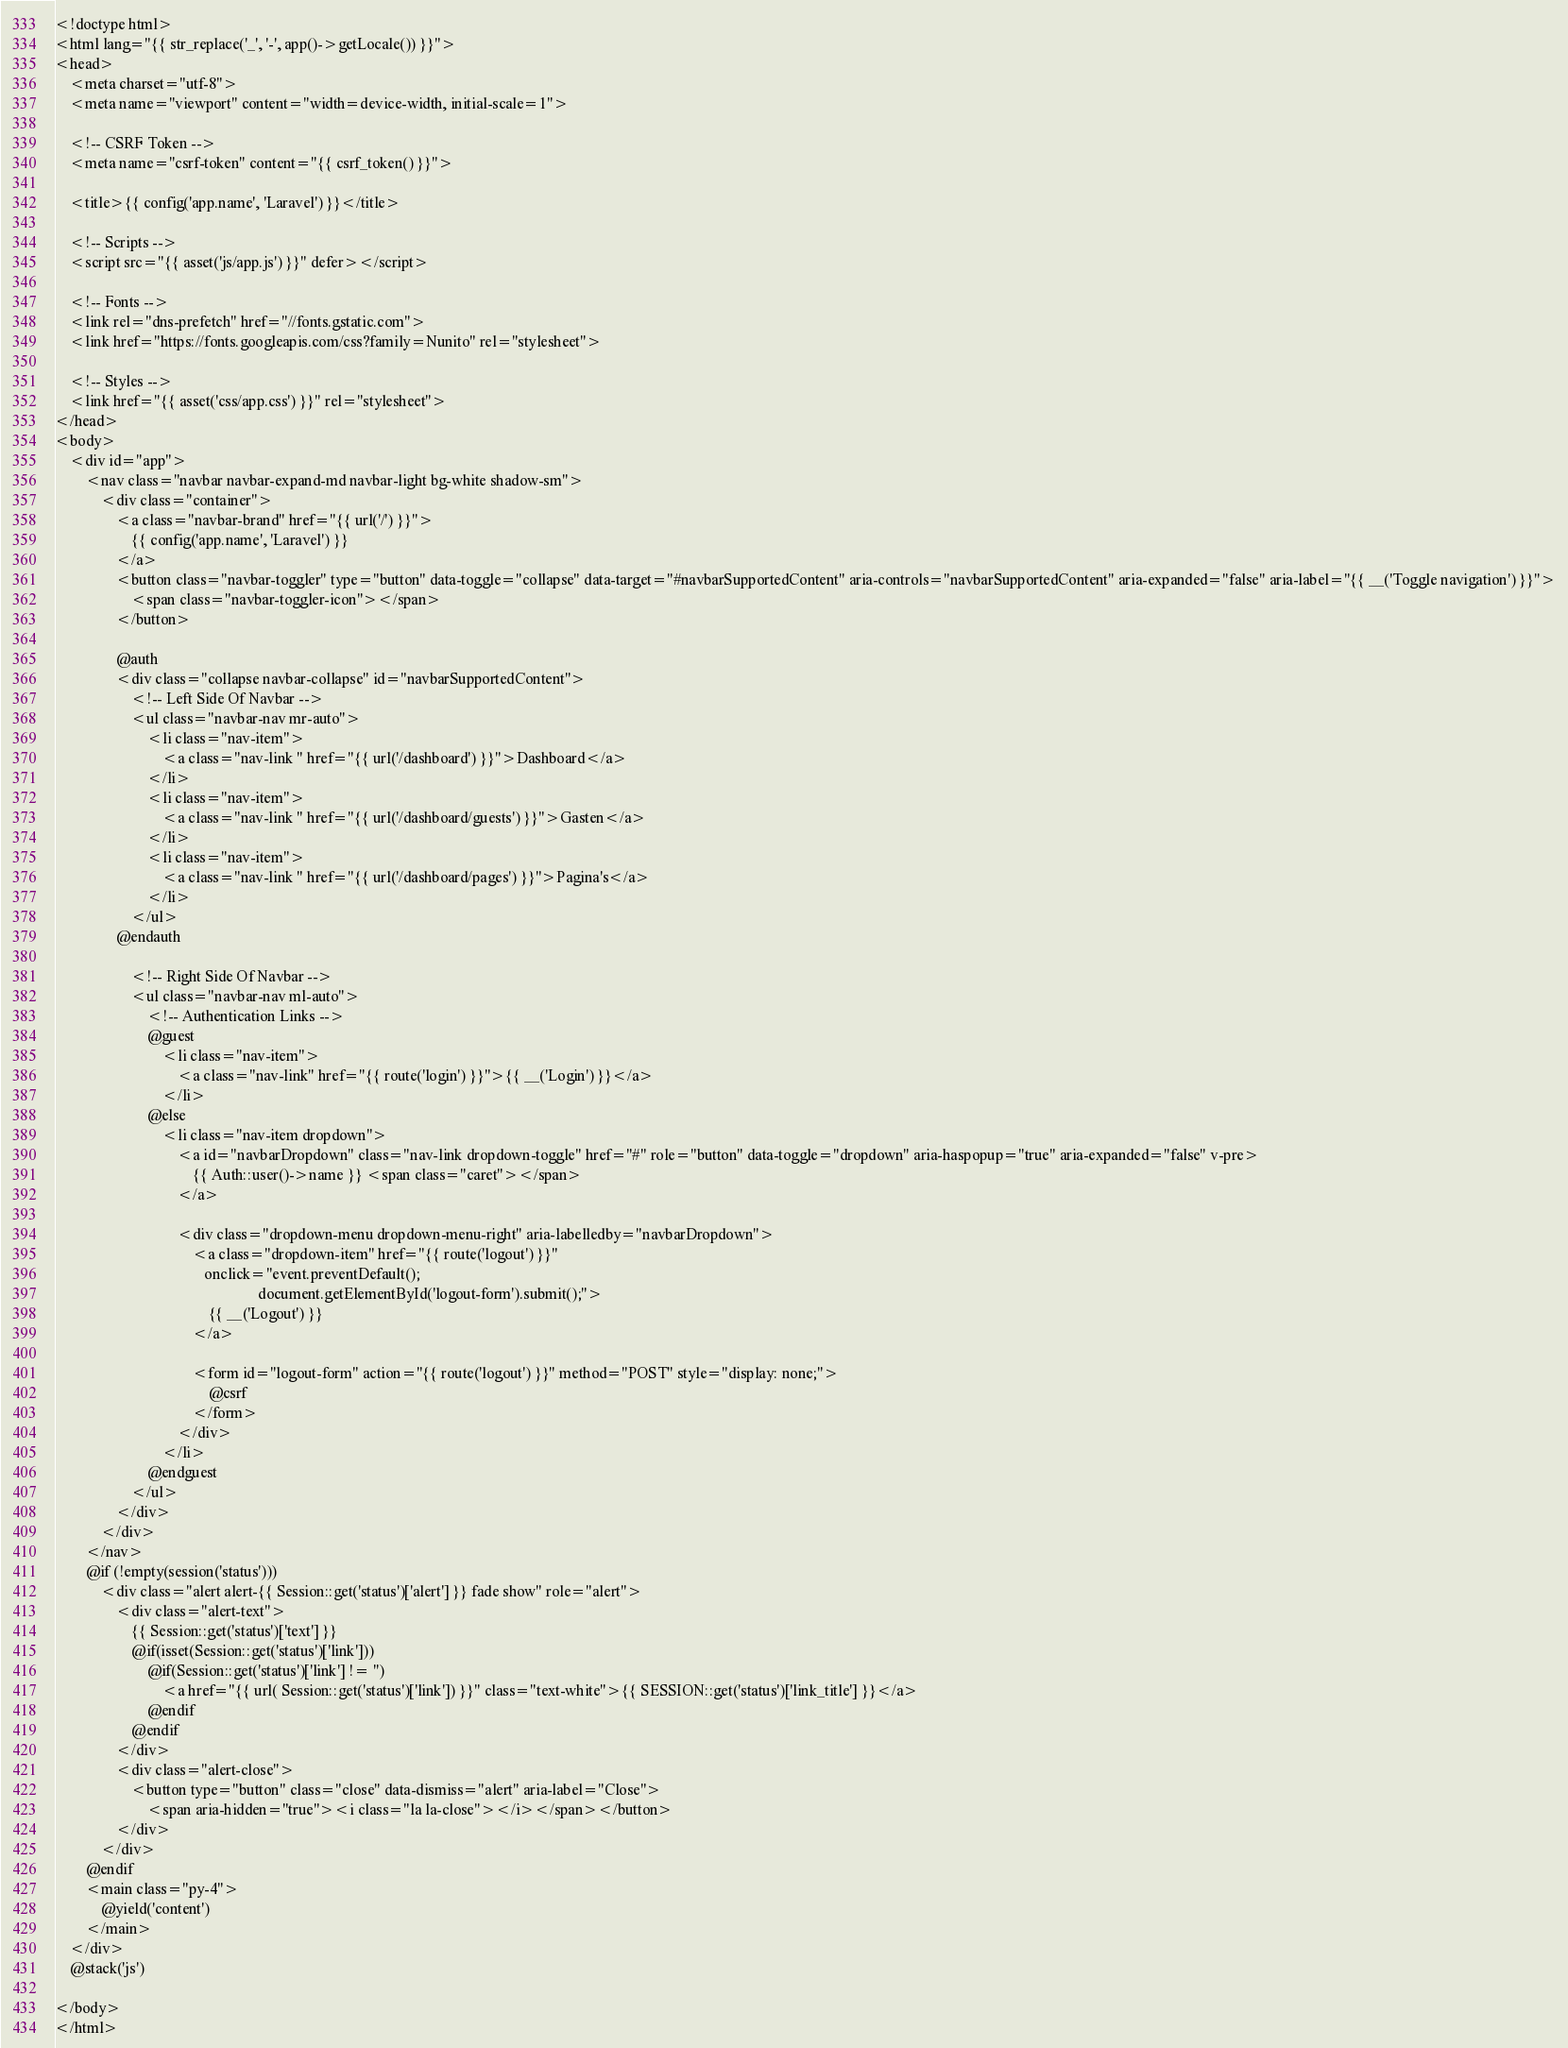Convert code to text. <code><loc_0><loc_0><loc_500><loc_500><_PHP_><!doctype html>
<html lang="{{ str_replace('_', '-', app()->getLocale()) }}">
<head>
    <meta charset="utf-8">
    <meta name="viewport" content="width=device-width, initial-scale=1">

    <!-- CSRF Token -->
    <meta name="csrf-token" content="{{ csrf_token() }}">

    <title>{{ config('app.name', 'Laravel') }}</title>

    <!-- Scripts -->
    <script src="{{ asset('js/app.js') }}" defer></script>

    <!-- Fonts -->
    <link rel="dns-prefetch" href="//fonts.gstatic.com">
    <link href="https://fonts.googleapis.com/css?family=Nunito" rel="stylesheet">

    <!-- Styles -->
    <link href="{{ asset('css/app.css') }}" rel="stylesheet">
</head>
<body>
    <div id="app">
        <nav class="navbar navbar-expand-md navbar-light bg-white shadow-sm">
            <div class="container">
                <a class="navbar-brand" href="{{ url('/') }}">
                    {{ config('app.name', 'Laravel') }}
                </a>
                <button class="navbar-toggler" type="button" data-toggle="collapse" data-target="#navbarSupportedContent" aria-controls="navbarSupportedContent" aria-expanded="false" aria-label="{{ __('Toggle navigation') }}">
                    <span class="navbar-toggler-icon"></span>
                </button>

                @auth
                <div class="collapse navbar-collapse" id="navbarSupportedContent">
                    <!-- Left Side Of Navbar -->
                    <ul class="navbar-nav mr-auto">
                        <li class="nav-item">
                            <a class="nav-link " href="{{ url('/dashboard') }}">Dashboard</a>
                        </li>
                        <li class="nav-item">
                            <a class="nav-link " href="{{ url('/dashboard/guests') }}">Gasten</a>
                        </li>
                        <li class="nav-item">
                            <a class="nav-link " href="{{ url('/dashboard/pages') }}">Pagina's</a>
                        </li>
                    </ul>
                @endauth

                    <!-- Right Side Of Navbar -->
                    <ul class="navbar-nav ml-auto">
                        <!-- Authentication Links -->
                        @guest
                            <li class="nav-item">
                                <a class="nav-link" href="{{ route('login') }}">{{ __('Login') }}</a>
                            </li>
                        @else
                            <li class="nav-item dropdown">
                                <a id="navbarDropdown" class="nav-link dropdown-toggle" href="#" role="button" data-toggle="dropdown" aria-haspopup="true" aria-expanded="false" v-pre>
                                    {{ Auth::user()->name }} <span class="caret"></span>
                                </a>

                                <div class="dropdown-menu dropdown-menu-right" aria-labelledby="navbarDropdown">
                                    <a class="dropdown-item" href="{{ route('logout') }}"
                                       onclick="event.preventDefault();
                                                     document.getElementById('logout-form').submit();">
                                        {{ __('Logout') }}
                                    </a>

                                    <form id="logout-form" action="{{ route('logout') }}" method="POST" style="display: none;">
                                        @csrf
                                    </form>
                                </div>
                            </li>
                        @endguest
                    </ul>
                </div>
            </div>
        </nav>
        @if (!empty(session('status')))
            <div class="alert alert-{{ Session::get('status')['alert'] }} fade show" role="alert">
                <div class="alert-text">
                    {{ Session::get('status')['text'] }}
                    @if(isset(Session::get('status')['link']))
                        @if(Session::get('status')['link'] != '')
                            <a href="{{ url( Session::get('status')['link']) }}" class="text-white">{{ SESSION::get('status')['link_title'] }}</a>
                        @endif
                    @endif
                </div>
                <div class="alert-close">
                    <button type="button" class="close" data-dismiss="alert" aria-label="Close">
                        <span aria-hidden="true"><i class="la la-close"></i></span></button>
                </div>
            </div>
        @endif
        <main class="py-4">
            @yield('content')
        </main>
    </div>
    @stack('js')

</body>
</html>
</code> 